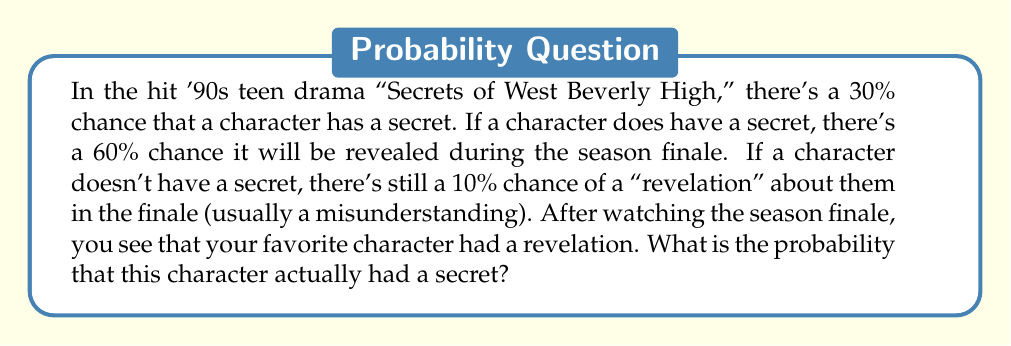Can you solve this math problem? Let's approach this using Bayes' theorem. We'll define the following events:
- S: The character has a secret
- R: A revelation occurs in the finale

We're given the following probabilities:
- P(S) = 0.30 (probability of having a secret)
- P(R|S) = 0.60 (probability of a revelation given there's a secret)
- P(R|not S) = 0.10 (probability of a revelation given there's no secret)

We want to find P(S|R), the probability that the character had a secret given that a revelation occurred.

Bayes' theorem states:

$$ P(S|R) = \frac{P(R|S) \cdot P(S)}{P(R)} $$

To find P(R), we use the law of total probability:

$$ P(R) = P(R|S) \cdot P(S) + P(R|not S) \cdot P(not S) $$

Let's calculate step by step:

1) P(not S) = 1 - P(S) = 1 - 0.30 = 0.70

2) P(R) = (0.60 * 0.30) + (0.10 * 0.70) = 0.18 + 0.07 = 0.25

Now we can apply Bayes' theorem:

$$ P(S|R) = \frac{0.60 \cdot 0.30}{0.25} = \frac{0.18}{0.25} = 0.72 $$

Therefore, the probability that the character actually had a secret, given that a revelation occurred, is 0.72 or 72%.
Answer: 0.72 or 72% 